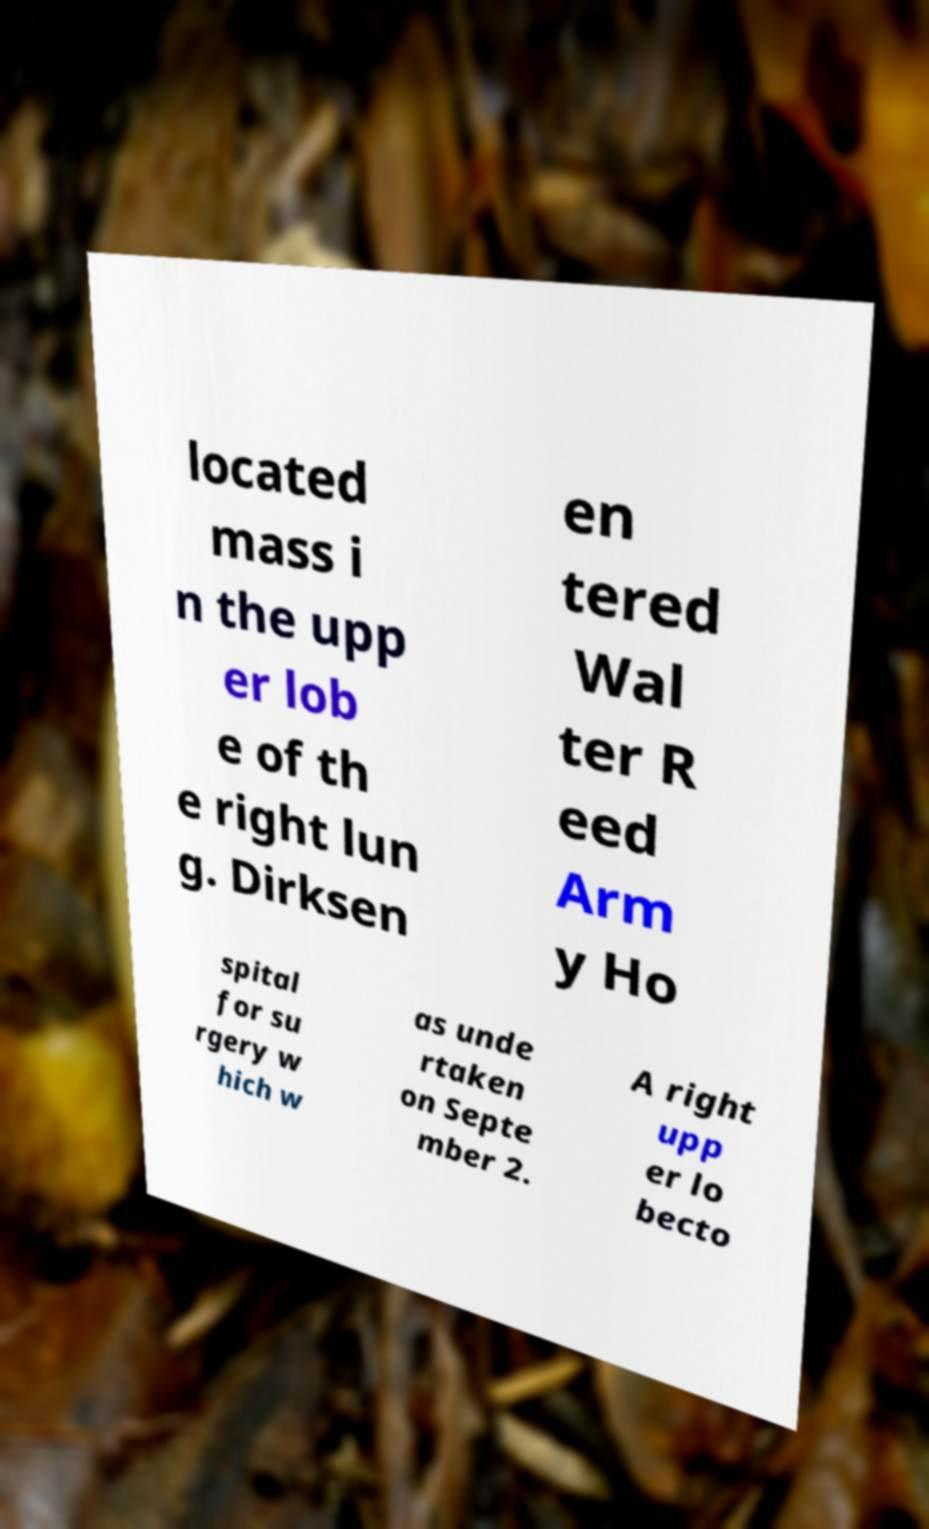Please identify and transcribe the text found in this image. located mass i n the upp er lob e of th e right lun g. Dirksen en tered Wal ter R eed Arm y Ho spital for su rgery w hich w as unde rtaken on Septe mber 2. A right upp er lo becto 